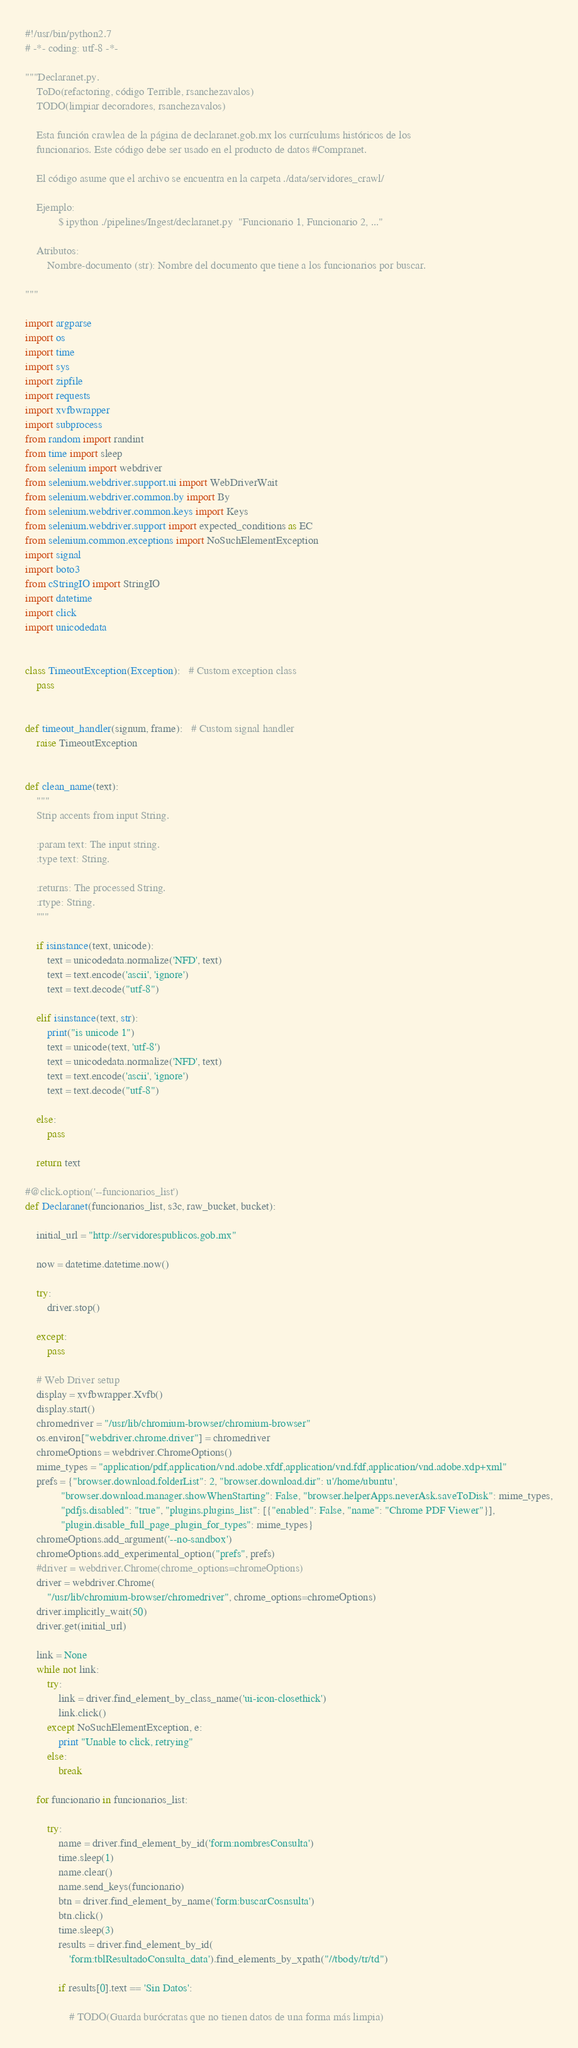Convert code to text. <code><loc_0><loc_0><loc_500><loc_500><_Python_>#!/usr/bin/python2.7
# -*- coding: utf-8 -*-

"""Declaranet.py.
    ToDo(refactoring, código Terrible, rsanchezavalos)
    TODO(limpiar decoradores, rsanchezavalos)

    Esta función crawlea de la página de declaranet.gob.mx los currículums históricos de los 
    funcionarios. Este código debe ser usado en el producto de datos #Compranet.

    El código asume que el archivo se encuentra en la carpeta ./data/servidores_crawl/

    Ejemplo:
            $ ipython ./pipelines/Ingest/declaranet.py  "Funcionario 1, Funcionario 2, ..." 

    Atributos:
        Nombre-documento (str): Nombre del documento que tiene a los funcionarios por buscar.

"""

import argparse
import os
import time
import sys
import zipfile
import requests
import xvfbwrapper
import subprocess
from random import randint
from time import sleep
from selenium import webdriver
from selenium.webdriver.support.ui import WebDriverWait
from selenium.webdriver.common.by import By
from selenium.webdriver.common.keys import Keys
from selenium.webdriver.support import expected_conditions as EC
from selenium.common.exceptions import NoSuchElementException
import signal
import boto3
from cStringIO import StringIO
import datetime
import click
import unicodedata


class TimeoutException(Exception):   # Custom exception class
    pass


def timeout_handler(signum, frame):   # Custom signal handler
    raise TimeoutException


def clean_name(text):
    """
    Strip accents from input String.

    :param text: The input string.
    :type text: String.

    :returns: The processed String.
    :rtype: String.
    """

    if isinstance(text, unicode):
        text = unicodedata.normalize('NFD', text)
        text = text.encode('ascii', 'ignore')
        text = text.decode("utf-8")

    elif isinstance(text, str):
        print("is unicode 1")
        text = unicode(text, 'utf-8')
        text = unicodedata.normalize('NFD', text)
        text = text.encode('ascii', 'ignore')
        text = text.decode("utf-8")

    else:
        pass

    return text

#@click.option('--funcionarios_list') 
def Declaranet(funcionarios_list, s3c, raw_bucket, bucket):

    initial_url = "http://servidorespublicos.gob.mx"

    now = datetime.datetime.now()

    try:
        driver.stop()

    except:
        pass

    # Web Driver setup
    display = xvfbwrapper.Xvfb()
    display.start()
    chromedriver = "/usr/lib/chromium-browser/chromium-browser"
    os.environ["webdriver.chrome.driver"] = chromedriver
    chromeOptions = webdriver.ChromeOptions()
    mime_types = "application/pdf,application/vnd.adobe.xfdf,application/vnd.fdf,application/vnd.adobe.xdp+xml"
    prefs = {"browser.download.folderList": 2, "browser.download.dir": u'/home/ubuntu',
             "browser.download.manager.showWhenStarting": False, "browser.helperApps.neverAsk.saveToDisk": mime_types,
             "pdfjs.disabled": "true", "plugins.plugins_list": [{"enabled": False, "name": "Chrome PDF Viewer"}],
             "plugin.disable_full_page_plugin_for_types": mime_types}
    chromeOptions.add_argument('--no-sandbox')
    chromeOptions.add_experimental_option("prefs", prefs)
    #driver = webdriver.Chrome(chrome_options=chromeOptions)
    driver = webdriver.Chrome(
        "/usr/lib/chromium-browser/chromedriver", chrome_options=chromeOptions)
    driver.implicitly_wait(50)
    driver.get(initial_url)

    link = None
    while not link:
        try:
            link = driver.find_element_by_class_name('ui-icon-closethick')
            link.click()
        except NoSuchElementException, e:
            print "Unable to click, retrying"
        else:
            break

    for funcionario in funcionarios_list:

        try:
            name = driver.find_element_by_id('form:nombresConsulta')
            time.sleep(1)
            name.clear()
            name.send_keys(funcionario)
            btn = driver.find_element_by_name('form:buscarCosnsulta')
            btn.click()
            time.sleep(3)
            results = driver.find_element_by_id(
                'form:tblResultadoConsulta_data').find_elements_by_xpath("//tbody/tr/td")

            if results[0].text == 'Sin Datos':

                # TODO(Guarda burócratas que no tienen datos de una forma más limpia)</code> 